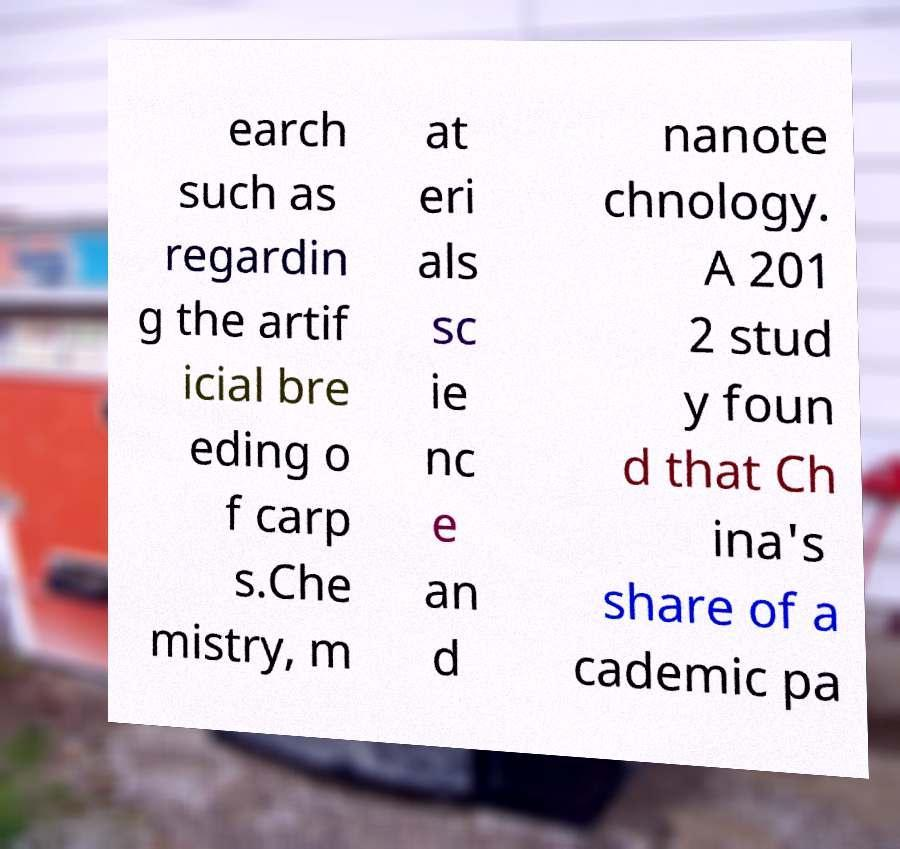Could you assist in decoding the text presented in this image and type it out clearly? earch such as regardin g the artif icial bre eding o f carp s.Che mistry, m at eri als sc ie nc e an d nanote chnology. A 201 2 stud y foun d that Ch ina's share of a cademic pa 